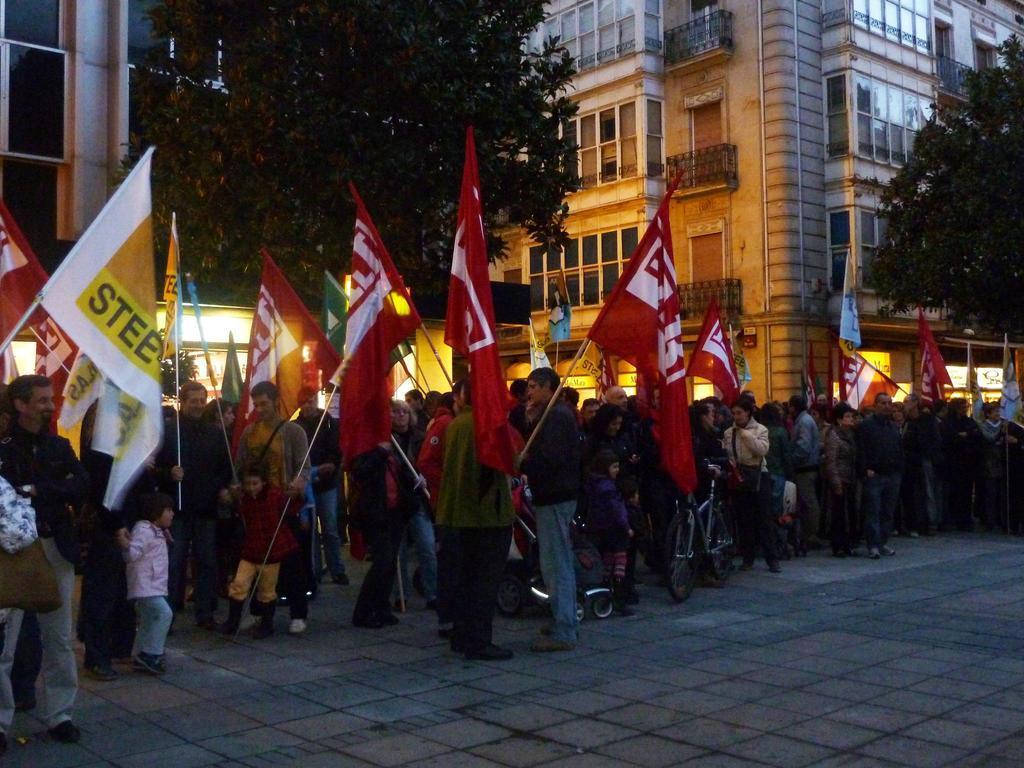Can you describe this image briefly? In the middle of the image few people are standing and holding some flags and bicycles. Behind them there are some trees and buildings. 